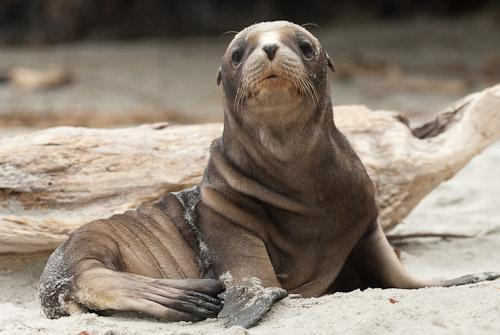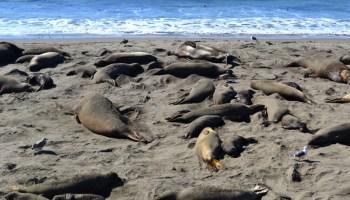The first image is the image on the left, the second image is the image on the right. For the images shown, is this caption "A single animal is looking toward the camera in the image on the left." true? Answer yes or no. Yes. The first image is the image on the left, the second image is the image on the right. Assess this claim about the two images: "In the foreground of an image, a left-facing small dark seal has its nose close to a bigger, paler seal.". Correct or not? Answer yes or no. No. 